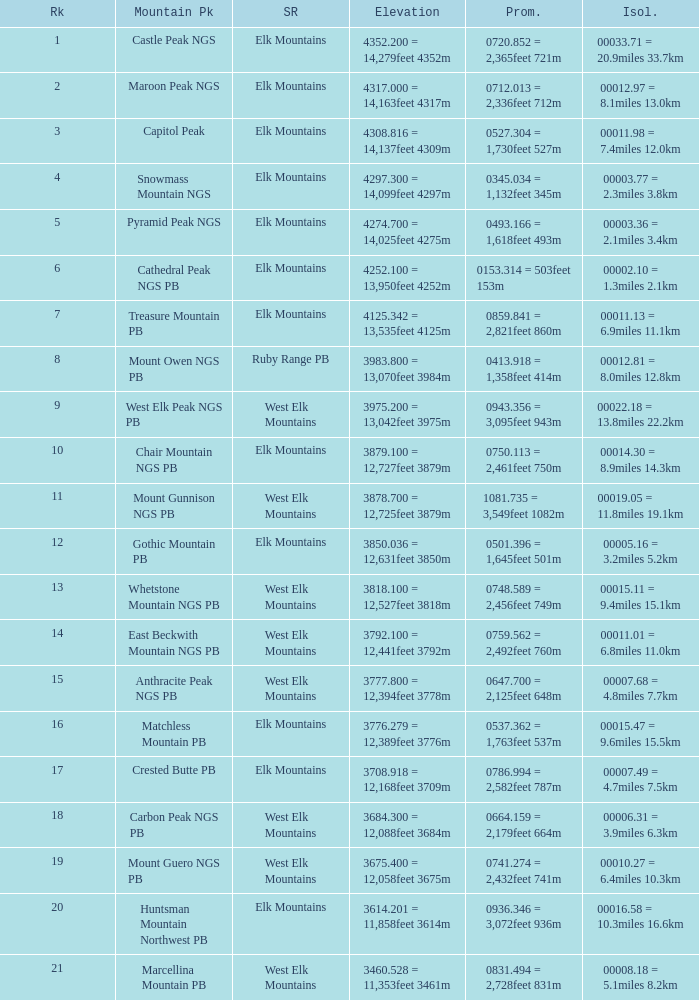Name the Rank of Rank Mountain Peak of crested butte pb? 17.0. 